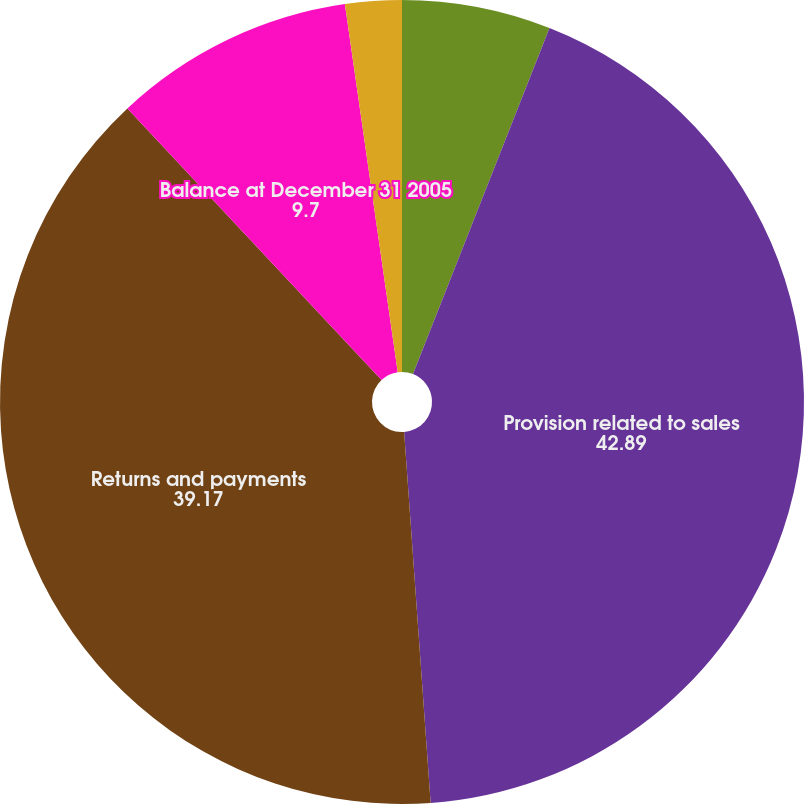<chart> <loc_0><loc_0><loc_500><loc_500><pie_chart><fcel>Balance at January 1 2005<fcel>Provision related to sales<fcel>Returns and payments<fcel>Balance at December 31 2005<fcel>Balance at December 31 2006<nl><fcel>5.98%<fcel>42.89%<fcel>39.17%<fcel>9.7%<fcel>2.27%<nl></chart> 